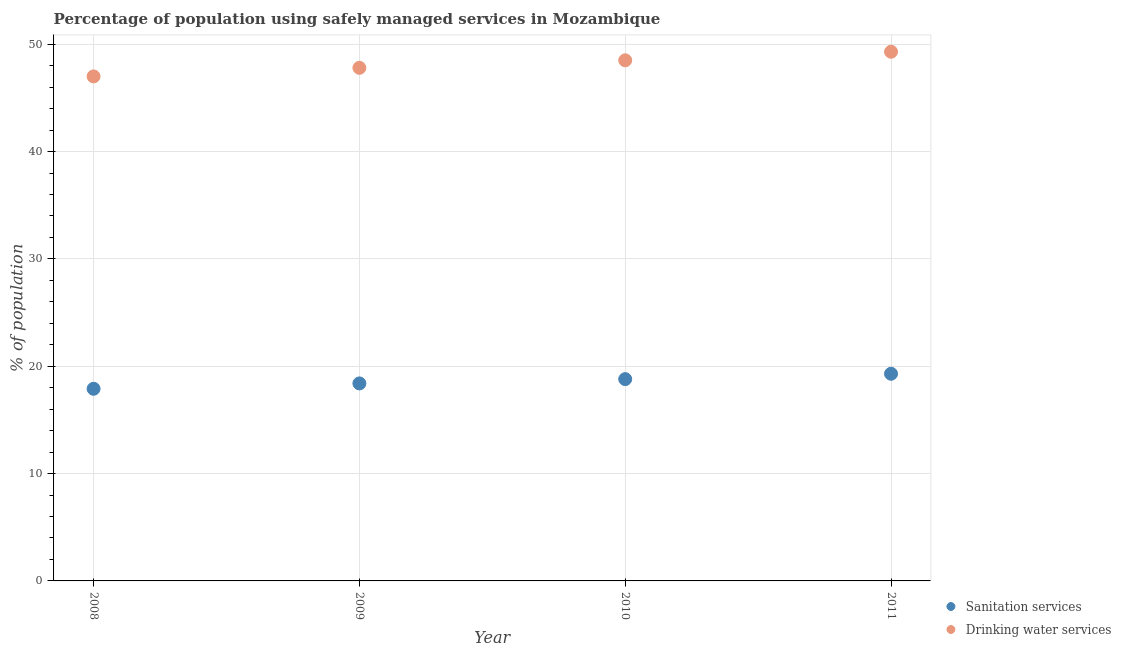How many different coloured dotlines are there?
Keep it short and to the point. 2. What is the percentage of population who used drinking water services in 2009?
Your response must be concise. 47.8. Across all years, what is the maximum percentage of population who used sanitation services?
Your answer should be compact. 19.3. Across all years, what is the minimum percentage of population who used sanitation services?
Offer a very short reply. 17.9. In which year was the percentage of population who used sanitation services minimum?
Provide a short and direct response. 2008. What is the total percentage of population who used sanitation services in the graph?
Keep it short and to the point. 74.4. What is the difference between the percentage of population who used sanitation services in 2009 and that in 2011?
Your response must be concise. -0.9. What is the difference between the percentage of population who used sanitation services in 2009 and the percentage of population who used drinking water services in 2008?
Offer a terse response. -28.6. What is the average percentage of population who used drinking water services per year?
Give a very brief answer. 48.15. In the year 2009, what is the difference between the percentage of population who used drinking water services and percentage of population who used sanitation services?
Give a very brief answer. 29.4. In how many years, is the percentage of population who used sanitation services greater than 20 %?
Offer a very short reply. 0. What is the ratio of the percentage of population who used sanitation services in 2008 to that in 2011?
Offer a terse response. 0.93. Is the percentage of population who used drinking water services in 2009 less than that in 2010?
Give a very brief answer. Yes. What is the difference between the highest and the second highest percentage of population who used drinking water services?
Offer a terse response. 0.8. What is the difference between the highest and the lowest percentage of population who used sanitation services?
Provide a short and direct response. 1.4. In how many years, is the percentage of population who used sanitation services greater than the average percentage of population who used sanitation services taken over all years?
Give a very brief answer. 2. Is the sum of the percentage of population who used drinking water services in 2009 and 2011 greater than the maximum percentage of population who used sanitation services across all years?
Offer a terse response. Yes. Is the percentage of population who used drinking water services strictly greater than the percentage of population who used sanitation services over the years?
Offer a very short reply. Yes. How many dotlines are there?
Offer a terse response. 2. How many years are there in the graph?
Provide a succinct answer. 4. Does the graph contain any zero values?
Offer a terse response. No. Where does the legend appear in the graph?
Your answer should be very brief. Bottom right. How many legend labels are there?
Provide a succinct answer. 2. How are the legend labels stacked?
Keep it short and to the point. Vertical. What is the title of the graph?
Give a very brief answer. Percentage of population using safely managed services in Mozambique. What is the label or title of the Y-axis?
Your answer should be compact. % of population. What is the % of population of Sanitation services in 2008?
Offer a terse response. 17.9. What is the % of population of Drinking water services in 2009?
Provide a succinct answer. 47.8. What is the % of population of Drinking water services in 2010?
Provide a succinct answer. 48.5. What is the % of population of Sanitation services in 2011?
Provide a short and direct response. 19.3. What is the % of population of Drinking water services in 2011?
Provide a short and direct response. 49.3. Across all years, what is the maximum % of population in Sanitation services?
Provide a short and direct response. 19.3. Across all years, what is the maximum % of population of Drinking water services?
Your answer should be compact. 49.3. Across all years, what is the minimum % of population of Sanitation services?
Make the answer very short. 17.9. Across all years, what is the minimum % of population of Drinking water services?
Your answer should be very brief. 47. What is the total % of population of Sanitation services in the graph?
Provide a short and direct response. 74.4. What is the total % of population in Drinking water services in the graph?
Ensure brevity in your answer.  192.6. What is the difference between the % of population in Sanitation services in 2008 and that in 2009?
Give a very brief answer. -0.5. What is the difference between the % of population in Drinking water services in 2008 and that in 2009?
Your response must be concise. -0.8. What is the difference between the % of population of Drinking water services in 2008 and that in 2010?
Keep it short and to the point. -1.5. What is the difference between the % of population of Sanitation services in 2008 and that in 2011?
Your answer should be very brief. -1.4. What is the difference between the % of population in Drinking water services in 2009 and that in 2010?
Your response must be concise. -0.7. What is the difference between the % of population in Drinking water services in 2010 and that in 2011?
Provide a succinct answer. -0.8. What is the difference between the % of population in Sanitation services in 2008 and the % of population in Drinking water services in 2009?
Make the answer very short. -29.9. What is the difference between the % of population of Sanitation services in 2008 and the % of population of Drinking water services in 2010?
Make the answer very short. -30.6. What is the difference between the % of population of Sanitation services in 2008 and the % of population of Drinking water services in 2011?
Keep it short and to the point. -31.4. What is the difference between the % of population in Sanitation services in 2009 and the % of population in Drinking water services in 2010?
Make the answer very short. -30.1. What is the difference between the % of population of Sanitation services in 2009 and the % of population of Drinking water services in 2011?
Offer a very short reply. -30.9. What is the difference between the % of population of Sanitation services in 2010 and the % of population of Drinking water services in 2011?
Keep it short and to the point. -30.5. What is the average % of population in Drinking water services per year?
Your answer should be very brief. 48.15. In the year 2008, what is the difference between the % of population in Sanitation services and % of population in Drinking water services?
Offer a very short reply. -29.1. In the year 2009, what is the difference between the % of population of Sanitation services and % of population of Drinking water services?
Offer a very short reply. -29.4. In the year 2010, what is the difference between the % of population in Sanitation services and % of population in Drinking water services?
Provide a succinct answer. -29.7. What is the ratio of the % of population of Sanitation services in 2008 to that in 2009?
Your answer should be very brief. 0.97. What is the ratio of the % of population in Drinking water services in 2008 to that in 2009?
Your response must be concise. 0.98. What is the ratio of the % of population of Sanitation services in 2008 to that in 2010?
Make the answer very short. 0.95. What is the ratio of the % of population in Drinking water services in 2008 to that in 2010?
Offer a very short reply. 0.97. What is the ratio of the % of population of Sanitation services in 2008 to that in 2011?
Your response must be concise. 0.93. What is the ratio of the % of population of Drinking water services in 2008 to that in 2011?
Your response must be concise. 0.95. What is the ratio of the % of population in Sanitation services in 2009 to that in 2010?
Ensure brevity in your answer.  0.98. What is the ratio of the % of population of Drinking water services in 2009 to that in 2010?
Offer a very short reply. 0.99. What is the ratio of the % of population of Sanitation services in 2009 to that in 2011?
Your answer should be very brief. 0.95. What is the ratio of the % of population of Drinking water services in 2009 to that in 2011?
Provide a short and direct response. 0.97. What is the ratio of the % of population of Sanitation services in 2010 to that in 2011?
Make the answer very short. 0.97. What is the ratio of the % of population in Drinking water services in 2010 to that in 2011?
Give a very brief answer. 0.98. What is the difference between the highest and the lowest % of population in Sanitation services?
Ensure brevity in your answer.  1.4. What is the difference between the highest and the lowest % of population in Drinking water services?
Make the answer very short. 2.3. 